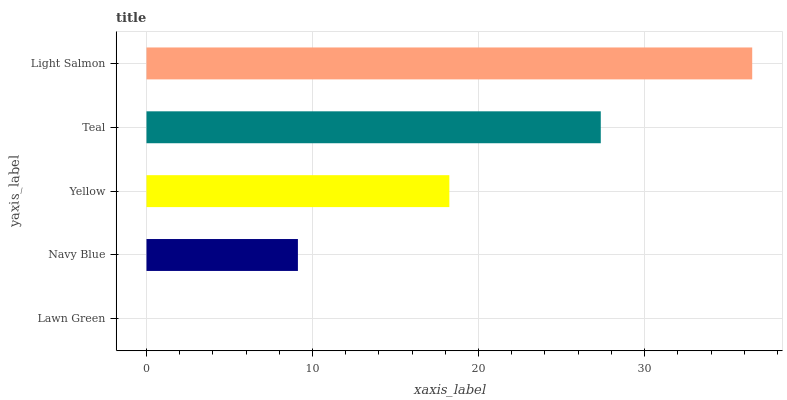Is Lawn Green the minimum?
Answer yes or no. Yes. Is Light Salmon the maximum?
Answer yes or no. Yes. Is Navy Blue the minimum?
Answer yes or no. No. Is Navy Blue the maximum?
Answer yes or no. No. Is Navy Blue greater than Lawn Green?
Answer yes or no. Yes. Is Lawn Green less than Navy Blue?
Answer yes or no. Yes. Is Lawn Green greater than Navy Blue?
Answer yes or no. No. Is Navy Blue less than Lawn Green?
Answer yes or no. No. Is Yellow the high median?
Answer yes or no. Yes. Is Yellow the low median?
Answer yes or no. Yes. Is Teal the high median?
Answer yes or no. No. Is Teal the low median?
Answer yes or no. No. 